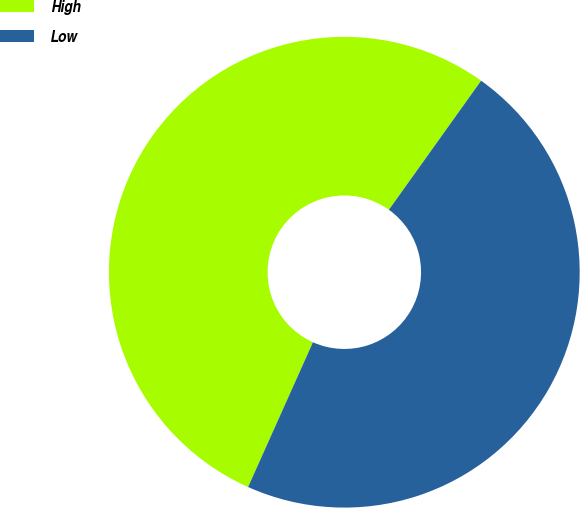<chart> <loc_0><loc_0><loc_500><loc_500><pie_chart><fcel>High<fcel>Low<nl><fcel>53.17%<fcel>46.83%<nl></chart> 